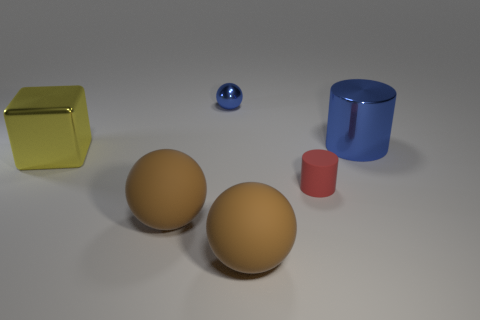What number of blue objects are either shiny blocks or shiny spheres?
Provide a succinct answer. 1. How many balls are behind the yellow object and to the left of the small metallic object?
Your response must be concise. 0. What material is the blue object to the left of the metallic thing on the right side of the large brown matte thing on the right side of the tiny sphere?
Your answer should be compact. Metal. How many cubes have the same material as the blue ball?
Offer a terse response. 1. There is a large shiny object that is the same color as the tiny shiny thing; what is its shape?
Make the answer very short. Cylinder. The shiny object that is the same size as the metal cube is what shape?
Your response must be concise. Cylinder. There is a cylinder that is the same color as the shiny sphere; what is its material?
Your answer should be compact. Metal. Are there any small red objects behind the large blue object?
Keep it short and to the point. No. Is there a big yellow metallic object that has the same shape as the small matte object?
Offer a terse response. No. Is the shape of the small object that is behind the large cube the same as the large object behind the large yellow metal thing?
Your response must be concise. No. 